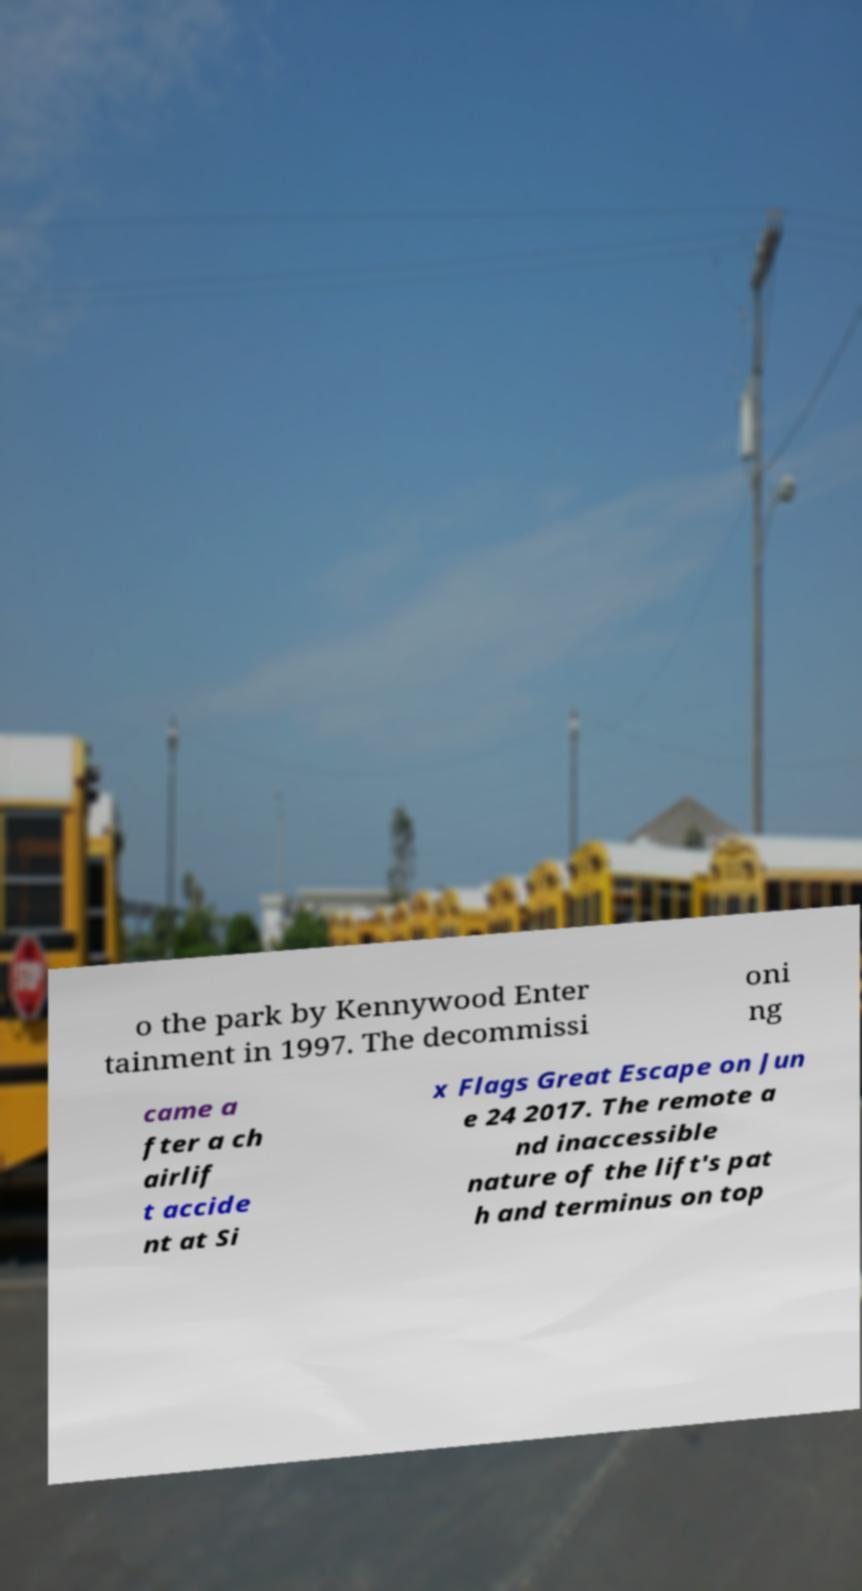Could you assist in decoding the text presented in this image and type it out clearly? o the park by Kennywood Enter tainment in 1997. The decommissi oni ng came a fter a ch airlif t accide nt at Si x Flags Great Escape on Jun e 24 2017. The remote a nd inaccessible nature of the lift's pat h and terminus on top 